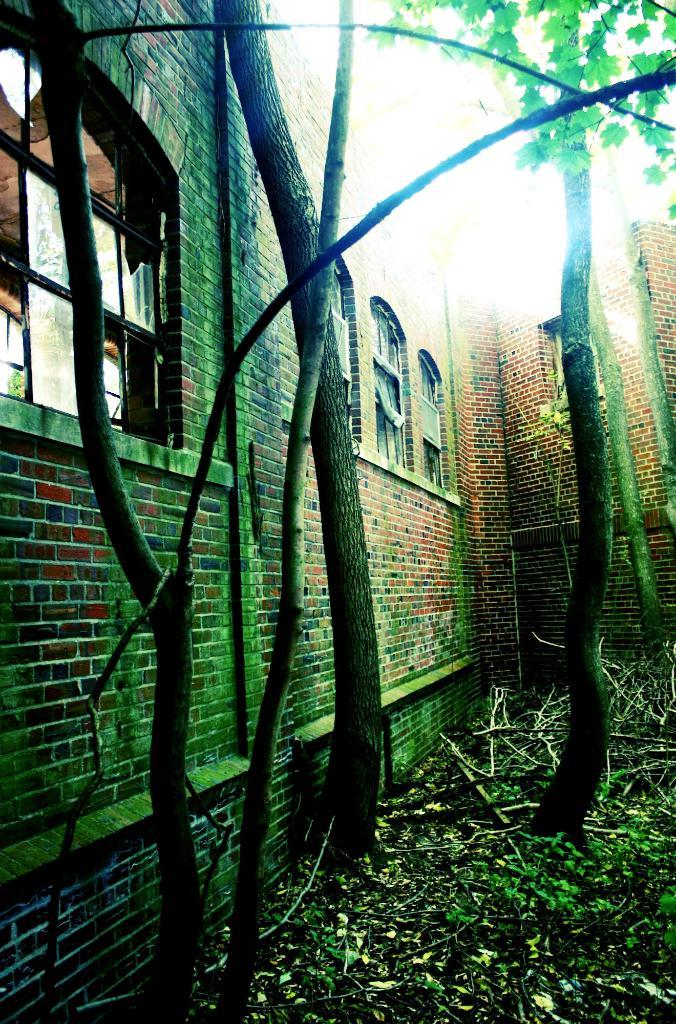What type of natural elements can be seen in the image? There are trees in the image. What type of man-made structures are present in the image? There are metal rods, windows, and walls in the image. What type of twig can be seen in the image? There is no twig present in the image. What type of insurance is being offered in the image? There is no insurance being offered in the image; it features trees, metal rods, windows, and walls. 